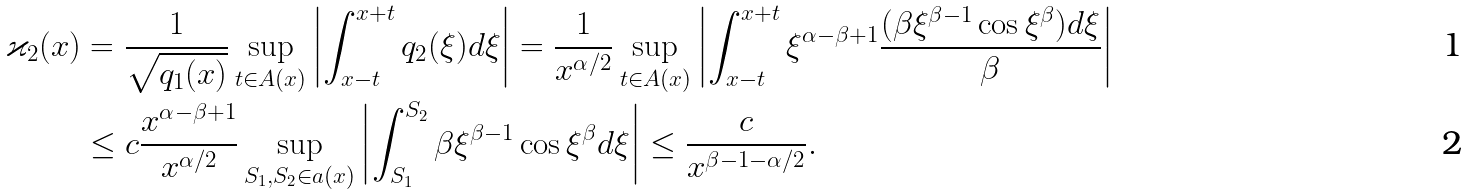Convert formula to latex. <formula><loc_0><loc_0><loc_500><loc_500>\varkappa _ { 2 } ( x ) & = \frac { 1 } { \sqrt { q _ { 1 } ( x ) } } \sup _ { t \in A ( x ) } \left | \int _ { x - t } ^ { x + t } q _ { 2 } ( \xi ) d \xi \right | = \frac { 1 } { x ^ { \alpha / 2 } } \sup _ { t \in A ( x ) } \left | \int _ { x - t } ^ { x + t } \xi ^ { \alpha - \beta + 1 } \frac { ( \beta \xi ^ { \beta - 1 } \cos \xi ^ { \beta } ) d \xi } { \beta } \right | \\ & \leq c \frac { x ^ { \alpha - \beta + 1 } } { x ^ { \alpha / 2 } } \sup _ { S _ { 1 } , S _ { 2 } \in a ( x ) } \left | \int _ { S _ { 1 } } ^ { S _ { 2 } } \beta \xi ^ { \beta - 1 } \cos \xi ^ { \beta } d \xi \right | \leq \frac { c } { x ^ { \beta - 1 - \alpha / 2 } } .</formula> 